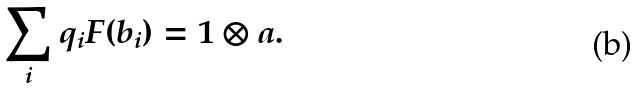Convert formula to latex. <formula><loc_0><loc_0><loc_500><loc_500>\sum _ { i } q _ { i } F ( b _ { i } ) = 1 \otimes a .</formula> 